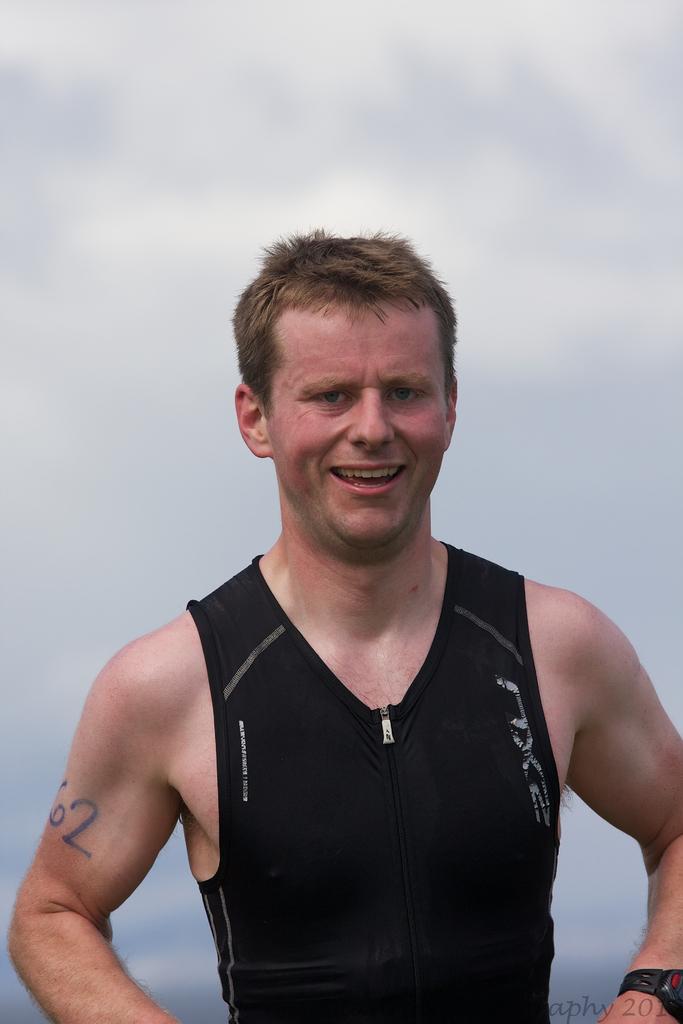Describe this image in one or two sentences. In this image we can see a person smiling and in the background, we can see the sky. 